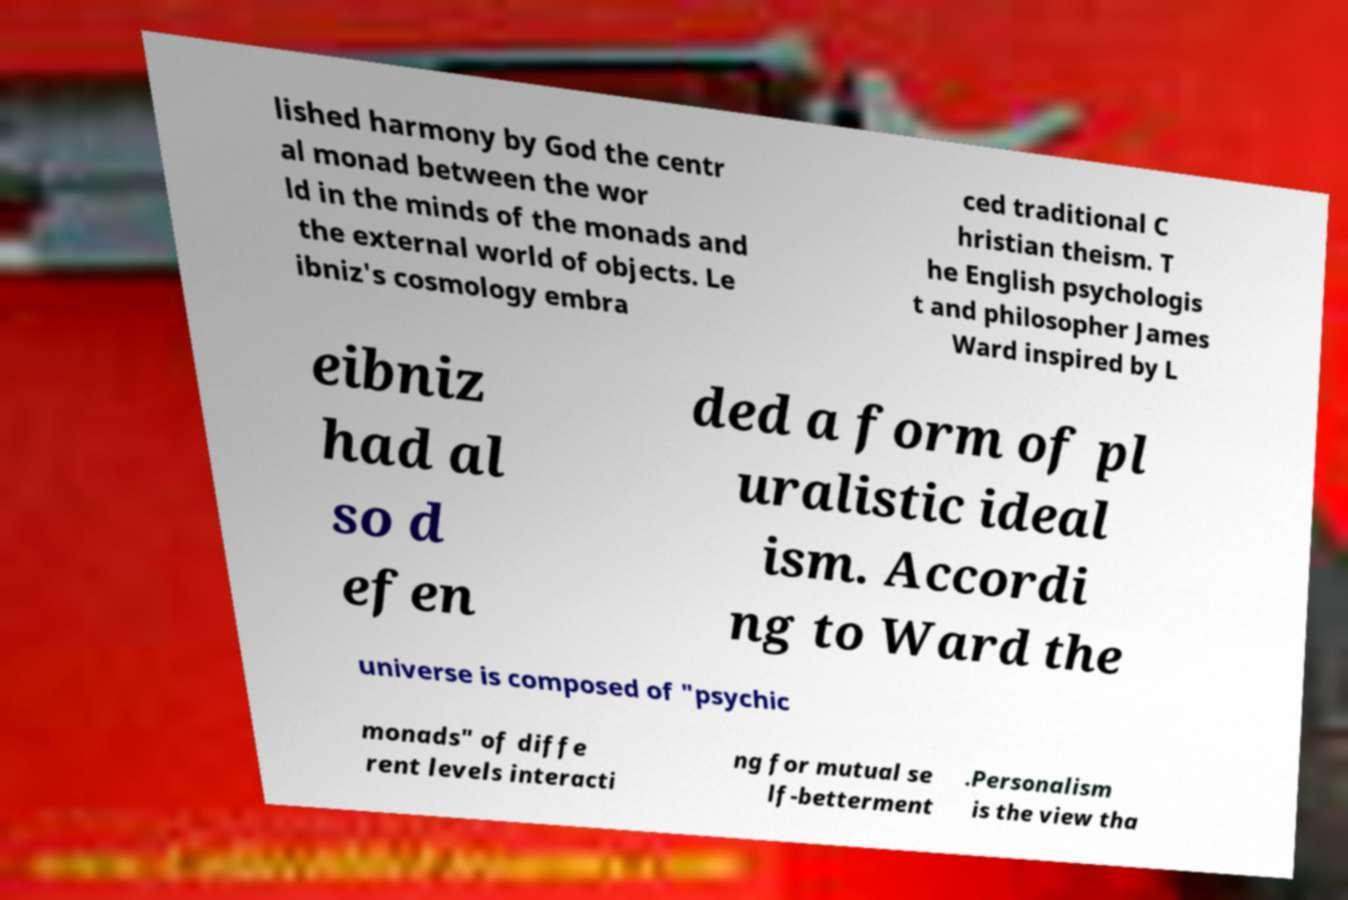Could you extract and type out the text from this image? lished harmony by God the centr al monad between the wor ld in the minds of the monads and the external world of objects. Le ibniz's cosmology embra ced traditional C hristian theism. T he English psychologis t and philosopher James Ward inspired by L eibniz had al so d efen ded a form of pl uralistic ideal ism. Accordi ng to Ward the universe is composed of "psychic monads" of diffe rent levels interacti ng for mutual se lf-betterment .Personalism is the view tha 